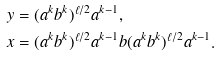<formula> <loc_0><loc_0><loc_500><loc_500>y & = ( a ^ { k } b ^ { k } ) ^ { \ell / 2 } a ^ { k - 1 } , \\ x & = ( a ^ { k } b ^ { k } ) ^ { \ell / 2 } a ^ { k - 1 } b ( a ^ { k } b ^ { k } ) ^ { \ell / 2 } a ^ { k - 1 } .</formula> 